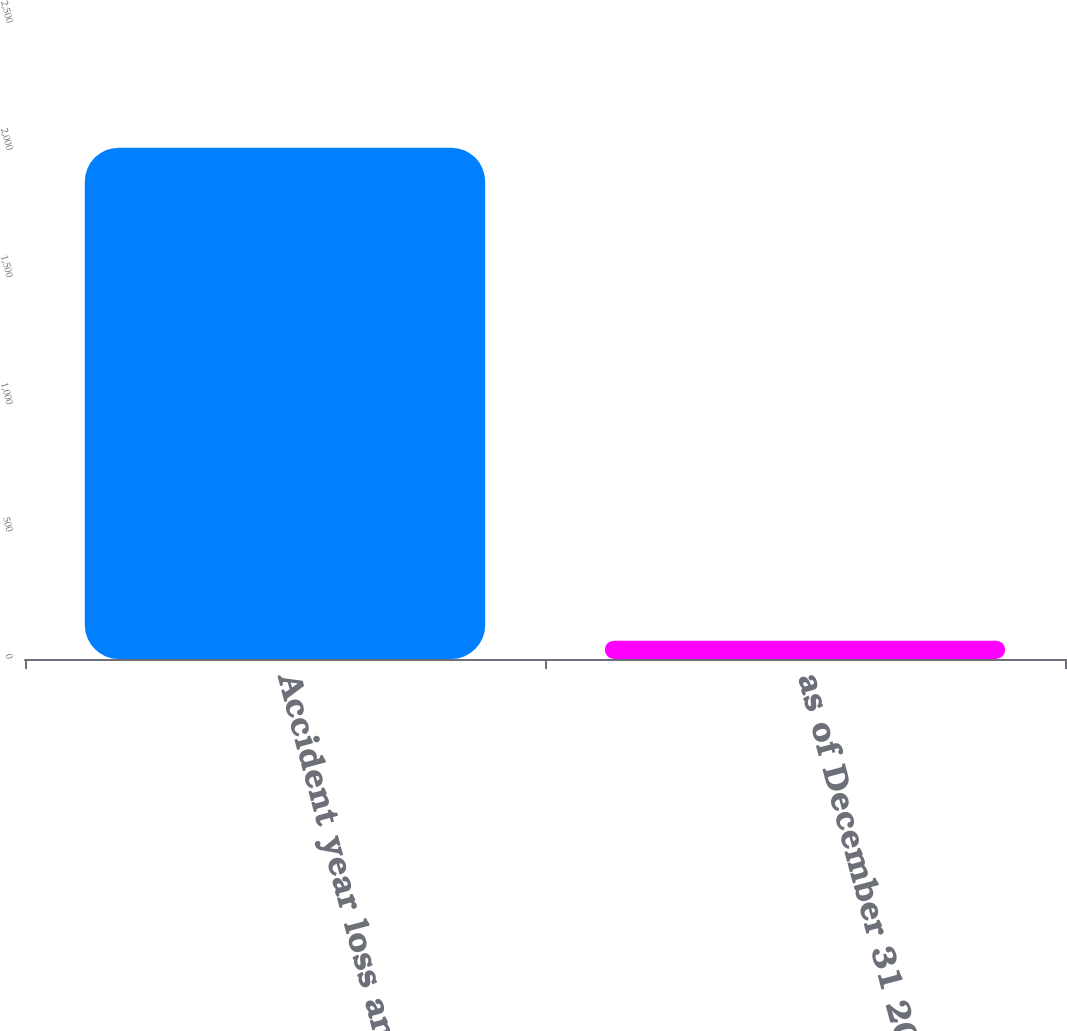Convert chart. <chart><loc_0><loc_0><loc_500><loc_500><bar_chart><fcel>Accident year loss and loss<fcel>as of December 31 2011<nl><fcel>2010<fcel>72<nl></chart> 